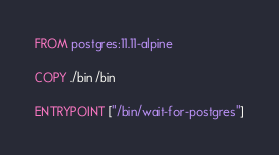Convert code to text. <code><loc_0><loc_0><loc_500><loc_500><_Dockerfile_>FROM postgres:11.11-alpine

COPY ./bin /bin

ENTRYPOINT ["/bin/wait-for-postgres"]
</code> 